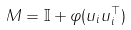Convert formula to latex. <formula><loc_0><loc_0><loc_500><loc_500>M = \mathbb { I } + \varphi ( u _ { i } u _ { i } ^ { \top } )</formula> 